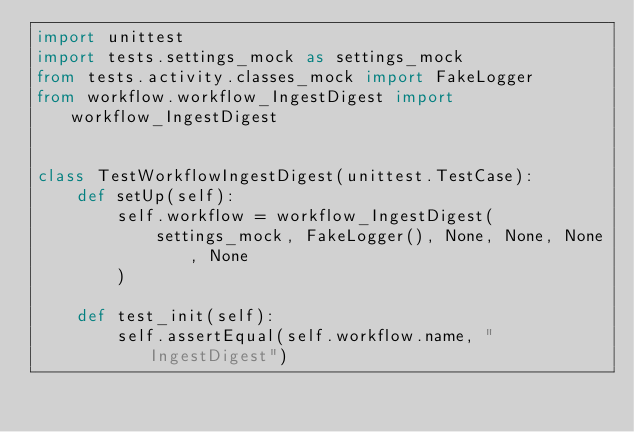<code> <loc_0><loc_0><loc_500><loc_500><_Python_>import unittest
import tests.settings_mock as settings_mock
from tests.activity.classes_mock import FakeLogger
from workflow.workflow_IngestDigest import workflow_IngestDigest


class TestWorkflowIngestDigest(unittest.TestCase):
    def setUp(self):
        self.workflow = workflow_IngestDigest(
            settings_mock, FakeLogger(), None, None, None, None
        )

    def test_init(self):
        self.assertEqual(self.workflow.name, "IngestDigest")
</code> 